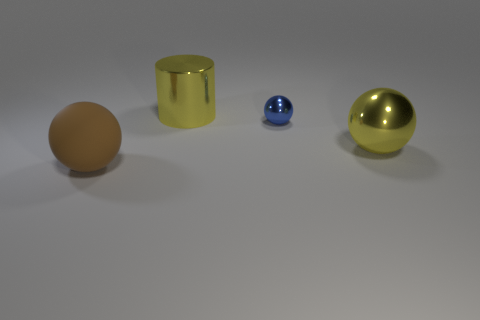There is a cylinder that is the same color as the big shiny sphere; what is its size?
Offer a very short reply. Large. Is the color of the metallic thing left of the tiny blue metallic sphere the same as the big sphere to the right of the large brown rubber thing?
Your answer should be very brief. Yes. What is the shape of the large object that is the same color as the big metallic ball?
Offer a very short reply. Cylinder. Do the big metal cylinder and the tiny shiny object have the same color?
Give a very brief answer. No. How many small spheres are the same color as the small thing?
Offer a very short reply. 0. Are there more big green rubber cylinders than tiny blue balls?
Offer a very short reply. No. There is a thing that is both in front of the yellow cylinder and on the left side of the tiny blue object; what is its size?
Offer a terse response. Large. Do the large object that is behind the yellow ball and the large sphere to the right of the brown rubber sphere have the same material?
Offer a very short reply. Yes. What is the shape of the yellow shiny thing that is the same size as the yellow ball?
Make the answer very short. Cylinder. Are there fewer yellow metal cylinders than tiny brown shiny objects?
Ensure brevity in your answer.  No. 